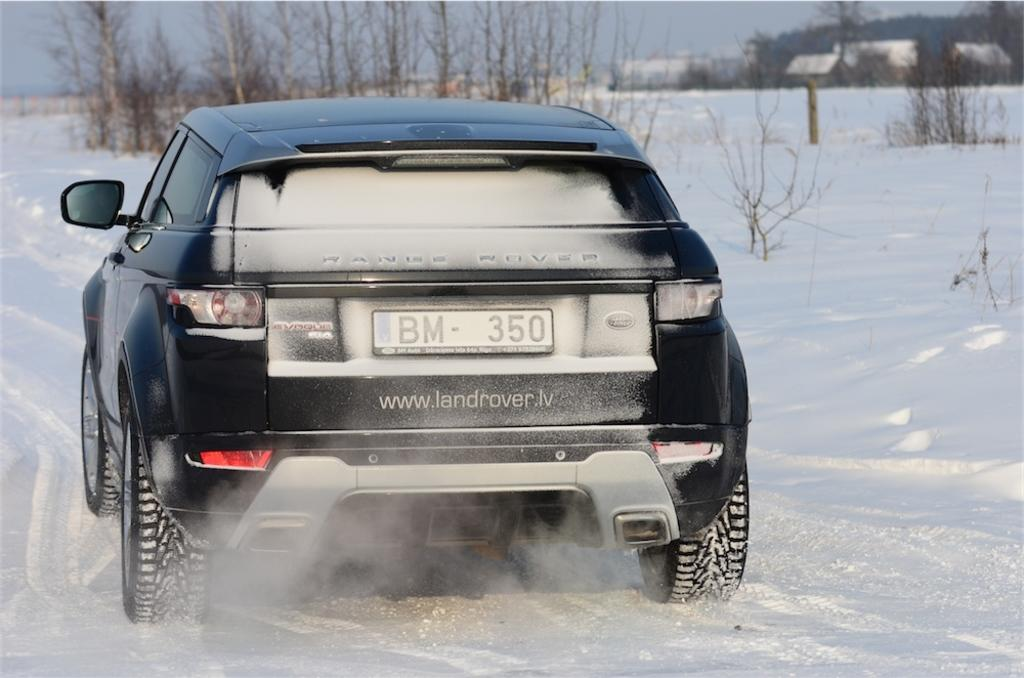<image>
Present a compact description of the photo's key features. Black Land Rover with the plate BM350 on the book. 